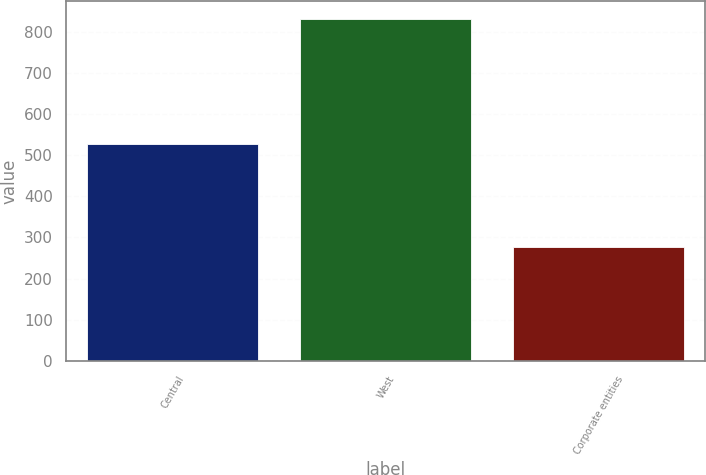Convert chart. <chart><loc_0><loc_0><loc_500><loc_500><bar_chart><fcel>Central<fcel>West<fcel>Corporate entities<nl><fcel>527.7<fcel>832.4<fcel>276.3<nl></chart> 